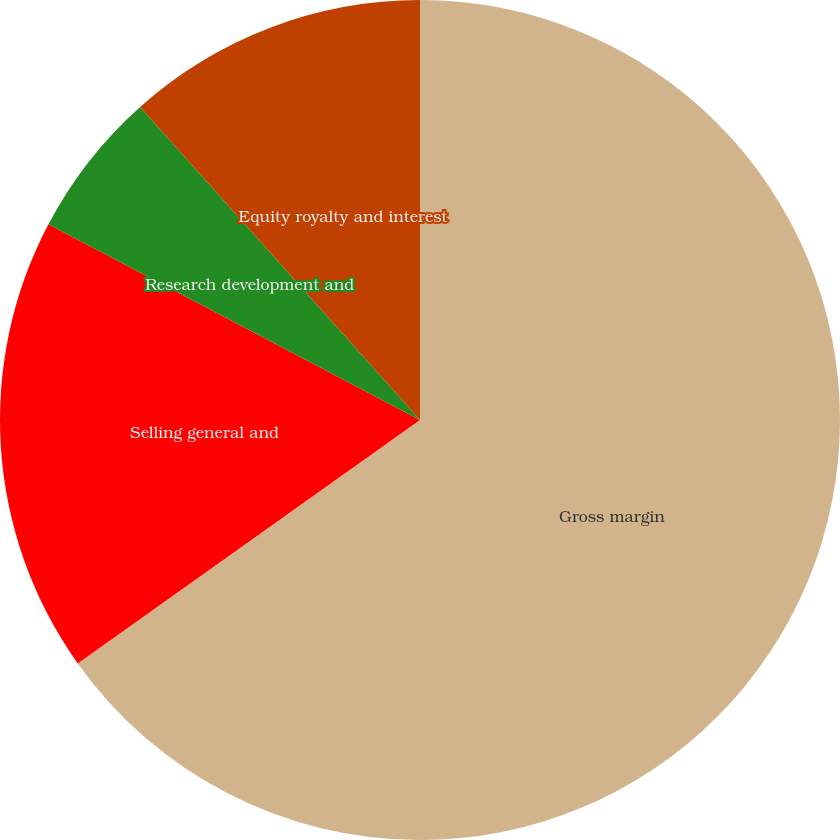<chart> <loc_0><loc_0><loc_500><loc_500><pie_chart><fcel>Gross margin<fcel>Selling general and<fcel>Research development and<fcel>Equity royalty and interest<nl><fcel>65.16%<fcel>17.56%<fcel>5.67%<fcel>11.61%<nl></chart> 